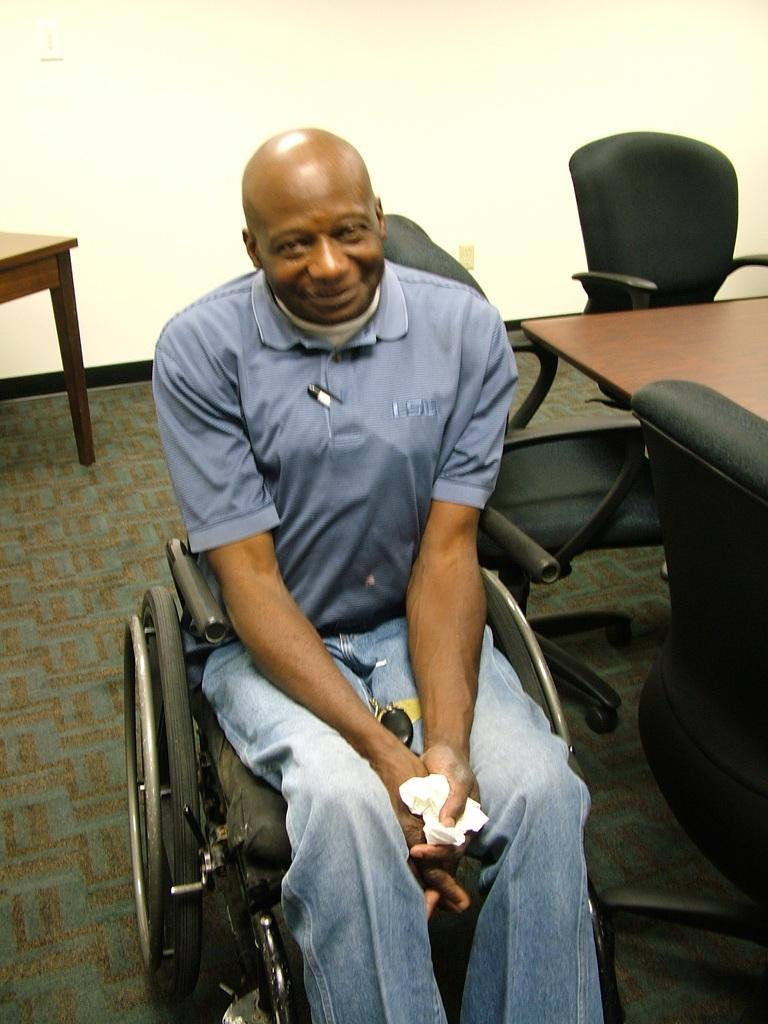Could you give a brief overview of what you see in this image? A man is sitting on a wheelchair. Behind him there is a table and many other chairs. In the background there is a wall. 